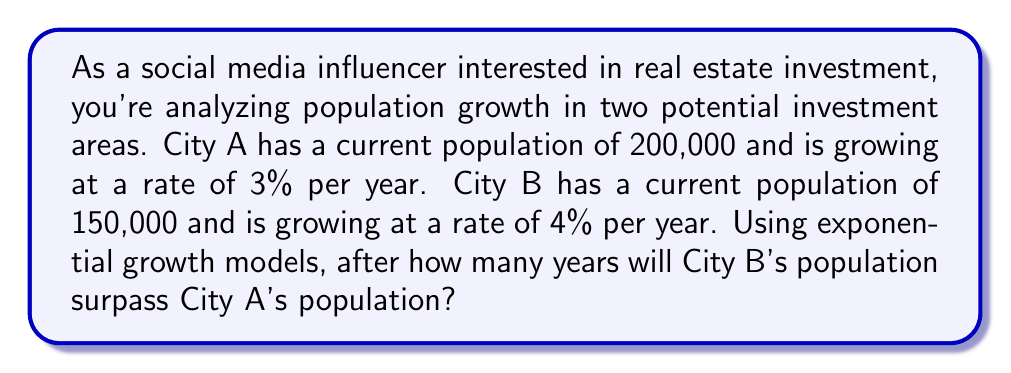Give your solution to this math problem. Let's approach this step-by-step using exponential growth models:

1) The exponential growth formula is:
   $P(t) = P_0 \cdot (1 + r)^t$
   Where $P(t)$ is the population at time $t$, $P_0$ is the initial population, $r$ is the growth rate, and $t$ is the time in years.

2) For City A:
   $P_A(t) = 200,000 \cdot (1 + 0.03)^t$

3) For City B:
   $P_B(t) = 150,000 \cdot (1 + 0.04)^t$

4) We need to find $t$ when $P_B(t) > P_A(t)$:

   $150,000 \cdot (1.04)^t > 200,000 \cdot (1.03)^t$

5) Dividing both sides by 150,000:

   $(1.04)^t > \frac{4}{3} \cdot (1.03)^t$

6) Taking the natural log of both sides:

   $t \cdot \ln(1.04) > \ln(\frac{4}{3}) + t \cdot \ln(1.03)$

7) Rearranging:

   $t \cdot [\ln(1.04) - \ln(1.03)] > \ln(\frac{4}{3})$

8) Solving for $t$:

   $t > \frac{\ln(\frac{4}{3})}{\ln(1.04) - \ln(1.03)} \approx 23.45$

9) Since we need a whole number of years, we round up to 24.
Answer: City B's population will surpass City A's population after 24 years. 